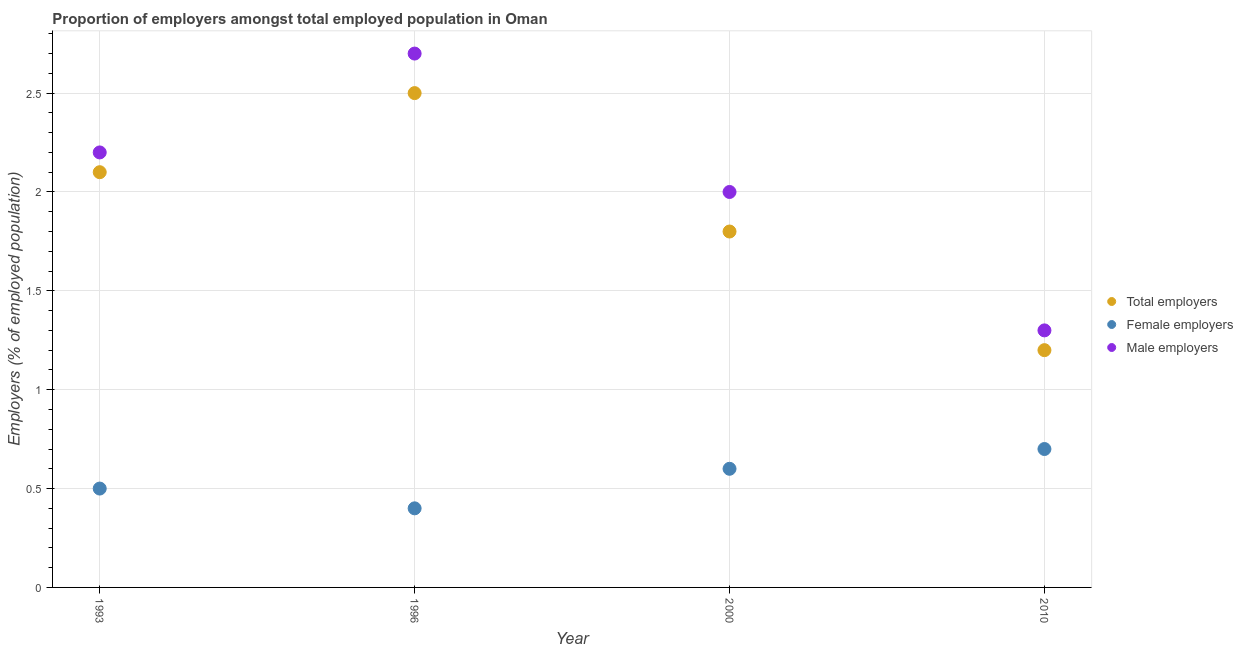How many different coloured dotlines are there?
Offer a terse response. 3. Is the number of dotlines equal to the number of legend labels?
Keep it short and to the point. Yes. What is the percentage of female employers in 1996?
Make the answer very short. 0.4. Across all years, what is the maximum percentage of female employers?
Ensure brevity in your answer.  0.7. Across all years, what is the minimum percentage of female employers?
Your response must be concise. 0.4. In which year was the percentage of male employers maximum?
Make the answer very short. 1996. In which year was the percentage of female employers minimum?
Give a very brief answer. 1996. What is the total percentage of total employers in the graph?
Your response must be concise. 7.6. What is the difference between the percentage of female employers in 1996 and that in 2010?
Your answer should be very brief. -0.3. What is the difference between the percentage of female employers in 2010 and the percentage of total employers in 2000?
Keep it short and to the point. -1.1. What is the average percentage of total employers per year?
Your answer should be very brief. 1.9. In the year 2000, what is the difference between the percentage of female employers and percentage of total employers?
Your answer should be compact. -1.2. In how many years, is the percentage of total employers greater than 1.5 %?
Keep it short and to the point. 3. What is the ratio of the percentage of male employers in 2000 to that in 2010?
Your answer should be very brief. 1.54. What is the difference between the highest and the second highest percentage of total employers?
Provide a short and direct response. 0.4. What is the difference between the highest and the lowest percentage of female employers?
Your answer should be very brief. 0.3. In how many years, is the percentage of total employers greater than the average percentage of total employers taken over all years?
Keep it short and to the point. 2. Is the sum of the percentage of female employers in 1993 and 2000 greater than the maximum percentage of male employers across all years?
Your answer should be compact. No. Is it the case that in every year, the sum of the percentage of total employers and percentage of female employers is greater than the percentage of male employers?
Your answer should be very brief. Yes. How many dotlines are there?
Give a very brief answer. 3. How many years are there in the graph?
Provide a succinct answer. 4. What is the difference between two consecutive major ticks on the Y-axis?
Your response must be concise. 0.5. Are the values on the major ticks of Y-axis written in scientific E-notation?
Your response must be concise. No. Does the graph contain any zero values?
Your answer should be compact. No. Does the graph contain grids?
Ensure brevity in your answer.  Yes. Where does the legend appear in the graph?
Ensure brevity in your answer.  Center right. How many legend labels are there?
Your answer should be very brief. 3. How are the legend labels stacked?
Make the answer very short. Vertical. What is the title of the graph?
Offer a very short reply. Proportion of employers amongst total employed population in Oman. Does "Industrial Nitrous Oxide" appear as one of the legend labels in the graph?
Keep it short and to the point. No. What is the label or title of the X-axis?
Ensure brevity in your answer.  Year. What is the label or title of the Y-axis?
Give a very brief answer. Employers (% of employed population). What is the Employers (% of employed population) of Total employers in 1993?
Ensure brevity in your answer.  2.1. What is the Employers (% of employed population) in Male employers in 1993?
Provide a succinct answer. 2.2. What is the Employers (% of employed population) in Female employers in 1996?
Your answer should be very brief. 0.4. What is the Employers (% of employed population) of Male employers in 1996?
Your answer should be compact. 2.7. What is the Employers (% of employed population) in Total employers in 2000?
Offer a terse response. 1.8. What is the Employers (% of employed population) in Female employers in 2000?
Offer a terse response. 0.6. What is the Employers (% of employed population) in Total employers in 2010?
Provide a succinct answer. 1.2. What is the Employers (% of employed population) of Female employers in 2010?
Give a very brief answer. 0.7. What is the Employers (% of employed population) of Male employers in 2010?
Offer a very short reply. 1.3. Across all years, what is the maximum Employers (% of employed population) in Female employers?
Provide a succinct answer. 0.7. Across all years, what is the maximum Employers (% of employed population) in Male employers?
Ensure brevity in your answer.  2.7. Across all years, what is the minimum Employers (% of employed population) of Total employers?
Your response must be concise. 1.2. Across all years, what is the minimum Employers (% of employed population) of Female employers?
Provide a succinct answer. 0.4. Across all years, what is the minimum Employers (% of employed population) of Male employers?
Your answer should be very brief. 1.3. What is the total Employers (% of employed population) of Female employers in the graph?
Offer a terse response. 2.2. What is the total Employers (% of employed population) in Male employers in the graph?
Your response must be concise. 8.2. What is the difference between the Employers (% of employed population) of Male employers in 1993 and that in 2010?
Give a very brief answer. 0.9. What is the difference between the Employers (% of employed population) of Total employers in 1996 and that in 2000?
Give a very brief answer. 0.7. What is the difference between the Employers (% of employed population) in Female employers in 1996 and that in 2000?
Provide a short and direct response. -0.2. What is the difference between the Employers (% of employed population) in Male employers in 1996 and that in 2000?
Make the answer very short. 0.7. What is the difference between the Employers (% of employed population) of Female employers in 1996 and that in 2010?
Your answer should be compact. -0.3. What is the difference between the Employers (% of employed population) in Male employers in 2000 and that in 2010?
Offer a very short reply. 0.7. What is the difference between the Employers (% of employed population) of Total employers in 1993 and the Employers (% of employed population) of Female employers in 1996?
Offer a very short reply. 1.7. What is the difference between the Employers (% of employed population) of Female employers in 1993 and the Employers (% of employed population) of Male employers in 1996?
Your response must be concise. -2.2. What is the difference between the Employers (% of employed population) of Total employers in 1993 and the Employers (% of employed population) of Female employers in 2000?
Give a very brief answer. 1.5. What is the difference between the Employers (% of employed population) of Total employers in 1993 and the Employers (% of employed population) of Male employers in 2000?
Your answer should be compact. 0.1. What is the difference between the Employers (% of employed population) in Female employers in 1993 and the Employers (% of employed population) in Male employers in 2010?
Offer a very short reply. -0.8. What is the difference between the Employers (% of employed population) in Total employers in 1996 and the Employers (% of employed population) in Male employers in 2000?
Your response must be concise. 0.5. What is the difference between the Employers (% of employed population) of Female employers in 1996 and the Employers (% of employed population) of Male employers in 2000?
Give a very brief answer. -1.6. What is the difference between the Employers (% of employed population) of Total employers in 1996 and the Employers (% of employed population) of Male employers in 2010?
Make the answer very short. 1.2. What is the difference between the Employers (% of employed population) of Total employers in 2000 and the Employers (% of employed population) of Female employers in 2010?
Offer a very short reply. 1.1. What is the difference between the Employers (% of employed population) of Female employers in 2000 and the Employers (% of employed population) of Male employers in 2010?
Your answer should be very brief. -0.7. What is the average Employers (% of employed population) in Total employers per year?
Your response must be concise. 1.9. What is the average Employers (% of employed population) in Female employers per year?
Give a very brief answer. 0.55. What is the average Employers (% of employed population) of Male employers per year?
Provide a succinct answer. 2.05. In the year 1993, what is the difference between the Employers (% of employed population) in Total employers and Employers (% of employed population) in Female employers?
Make the answer very short. 1.6. In the year 1993, what is the difference between the Employers (% of employed population) of Female employers and Employers (% of employed population) of Male employers?
Your response must be concise. -1.7. In the year 1996, what is the difference between the Employers (% of employed population) in Total employers and Employers (% of employed population) in Female employers?
Your response must be concise. 2.1. In the year 2000, what is the difference between the Employers (% of employed population) in Total employers and Employers (% of employed population) in Male employers?
Your answer should be very brief. -0.2. What is the ratio of the Employers (% of employed population) in Total employers in 1993 to that in 1996?
Give a very brief answer. 0.84. What is the ratio of the Employers (% of employed population) of Male employers in 1993 to that in 1996?
Your answer should be very brief. 0.81. What is the ratio of the Employers (% of employed population) in Male employers in 1993 to that in 2000?
Make the answer very short. 1.1. What is the ratio of the Employers (% of employed population) in Total employers in 1993 to that in 2010?
Offer a very short reply. 1.75. What is the ratio of the Employers (% of employed population) of Female employers in 1993 to that in 2010?
Give a very brief answer. 0.71. What is the ratio of the Employers (% of employed population) in Male employers in 1993 to that in 2010?
Make the answer very short. 1.69. What is the ratio of the Employers (% of employed population) in Total employers in 1996 to that in 2000?
Provide a succinct answer. 1.39. What is the ratio of the Employers (% of employed population) in Male employers in 1996 to that in 2000?
Keep it short and to the point. 1.35. What is the ratio of the Employers (% of employed population) in Total employers in 1996 to that in 2010?
Offer a very short reply. 2.08. What is the ratio of the Employers (% of employed population) of Male employers in 1996 to that in 2010?
Give a very brief answer. 2.08. What is the ratio of the Employers (% of employed population) of Female employers in 2000 to that in 2010?
Your answer should be compact. 0.86. What is the ratio of the Employers (% of employed population) of Male employers in 2000 to that in 2010?
Offer a very short reply. 1.54. What is the difference between the highest and the second highest Employers (% of employed population) in Female employers?
Make the answer very short. 0.1. 